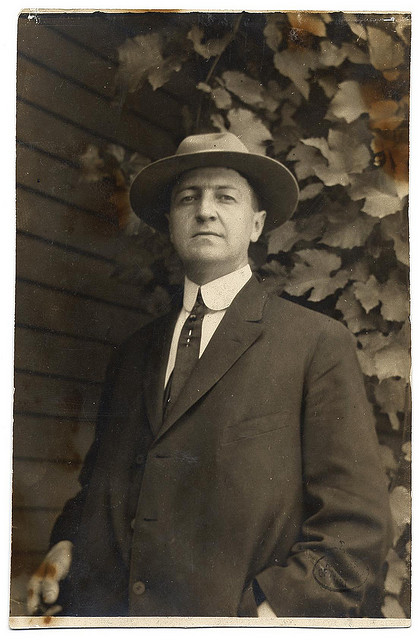<image>What kind of suit is that? I don't know what kind of suit this is. It could be a business suit, formal suit, oversized suit, double breasted suit or vintage suit. What kind of suit is that? I don't know what kind of suit it is. It can be a business suit, formal suit, oversized suit, or vintage suit. 